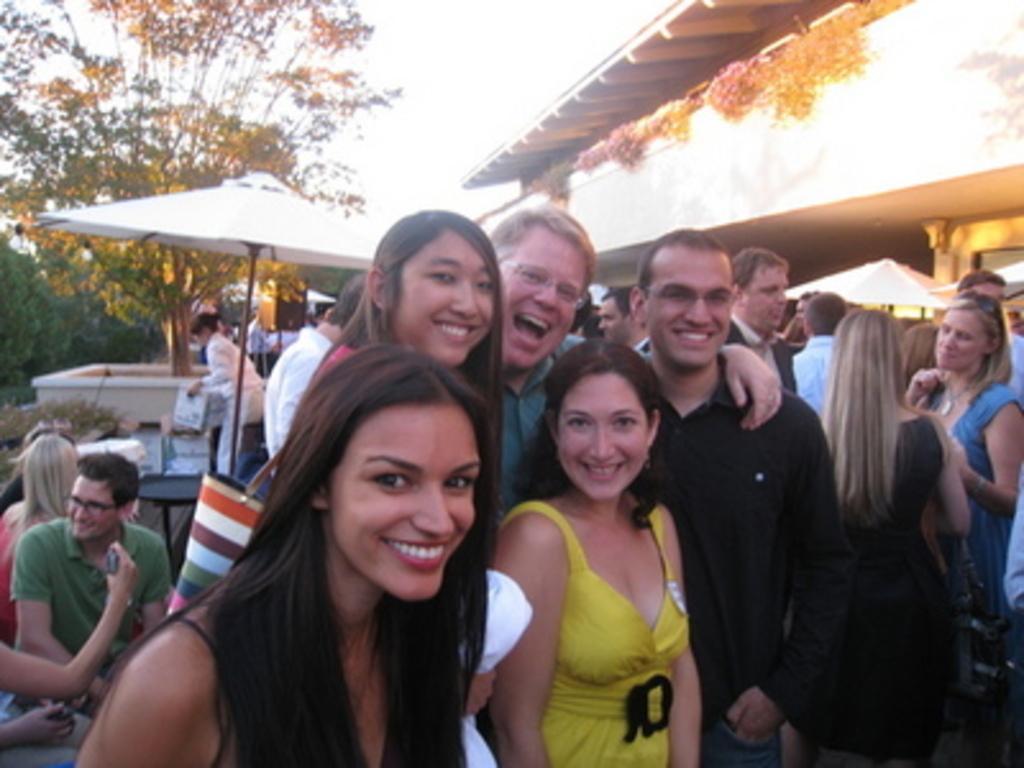Describe this image in one or two sentences. In this picture we can see a group of people where some are standing and smiling, bag, umbrellas, building, trees, poles and in the background we can see the sky. 